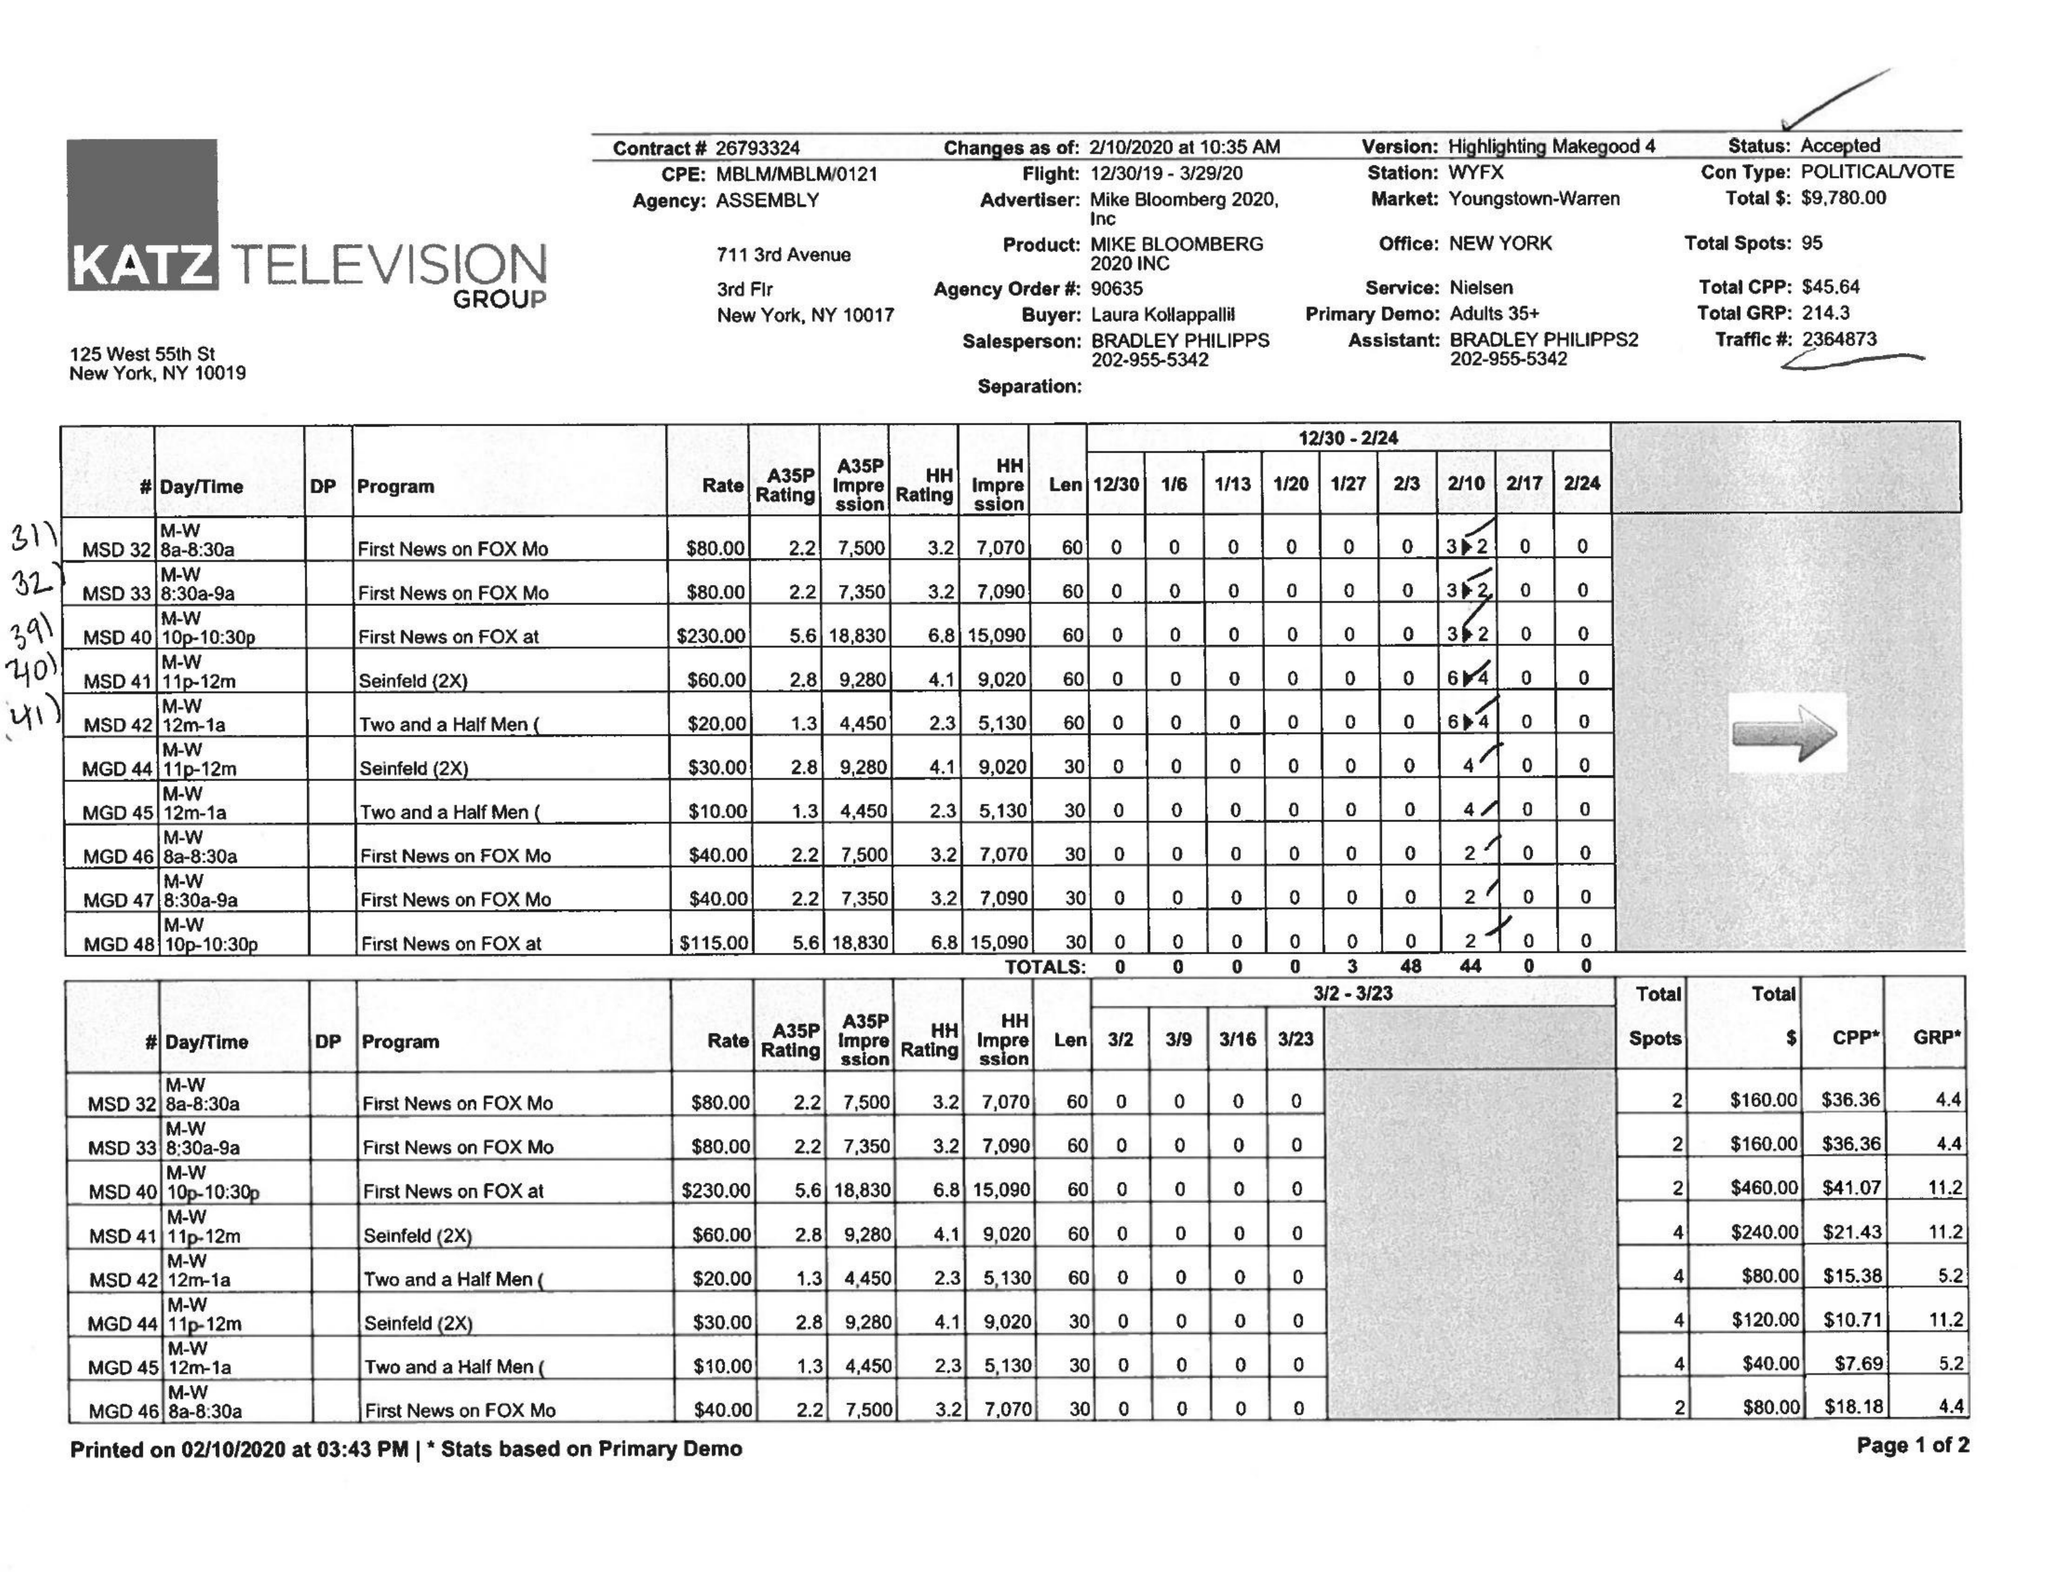What is the value for the advertiser?
Answer the question using a single word or phrase. MIKE BLOOMBERG 2020, INC 